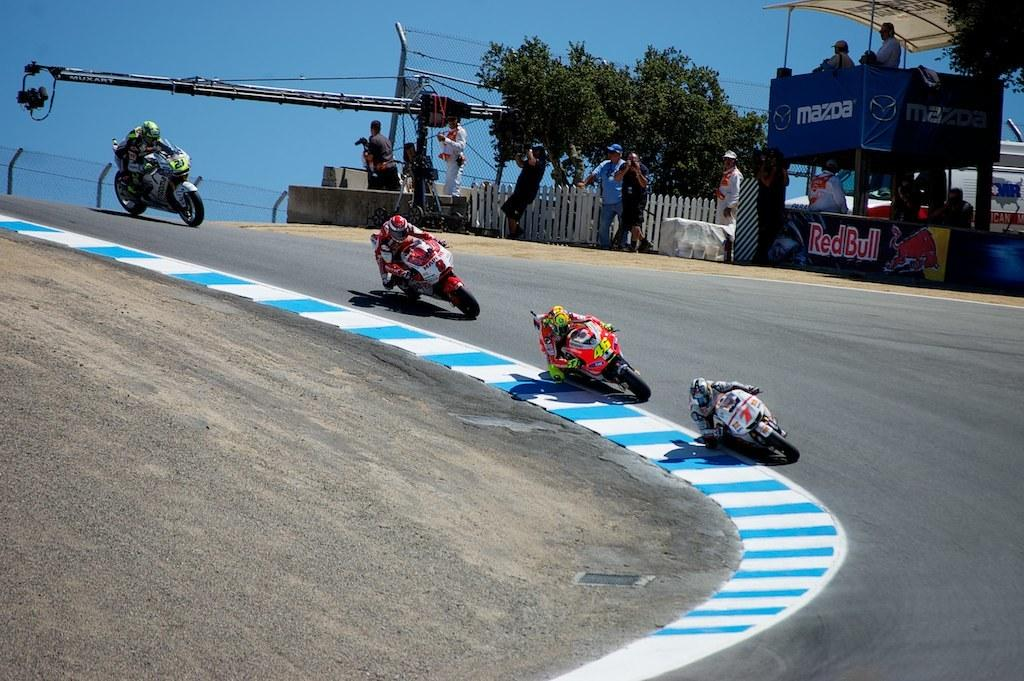What are the main subjects in the center of the image? There are people riding bikes in the center of the image. What can be seen separating the different areas in the image? There is a boundary in the image. Where are the people located who are not riding bikes? There are people as audience at the top side of the image. How many chickens are visible in the image? There are no chickens present in the image. What type of blade is being used by the people riding bikes? The image does not show any blades being used by the people riding bikes. 